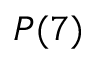Convert formula to latex. <formula><loc_0><loc_0><loc_500><loc_500>P ( 7 )</formula> 